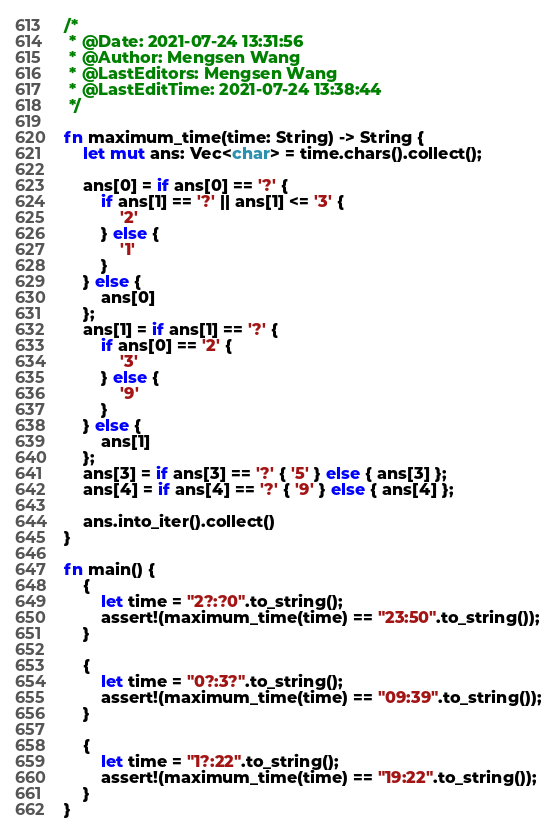<code> <loc_0><loc_0><loc_500><loc_500><_Rust_>/*
 * @Date: 2021-07-24 13:31:56
 * @Author: Mengsen Wang
 * @LastEditors: Mengsen Wang
 * @LastEditTime: 2021-07-24 13:38:44
 */

fn maximum_time(time: String) -> String {
    let mut ans: Vec<char> = time.chars().collect();

    ans[0] = if ans[0] == '?' {
        if ans[1] == '?' || ans[1] <= '3' {
            '2'
        } else {
            '1'
        }
    } else {
        ans[0]
    };
    ans[1] = if ans[1] == '?' {
        if ans[0] == '2' {
            '3'
        } else {
            '9'
        }
    } else {
        ans[1]
    };
    ans[3] = if ans[3] == '?' { '5' } else { ans[3] };
    ans[4] = if ans[4] == '?' { '9' } else { ans[4] };

    ans.into_iter().collect()
}

fn main() {
    {
        let time = "2?:?0".to_string();
        assert!(maximum_time(time) == "23:50".to_string());
    }

    {
        let time = "0?:3?".to_string();
        assert!(maximum_time(time) == "09:39".to_string());
    }

    {
        let time = "1?:22".to_string();
        assert!(maximum_time(time) == "19:22".to_string());
    }
}
</code> 